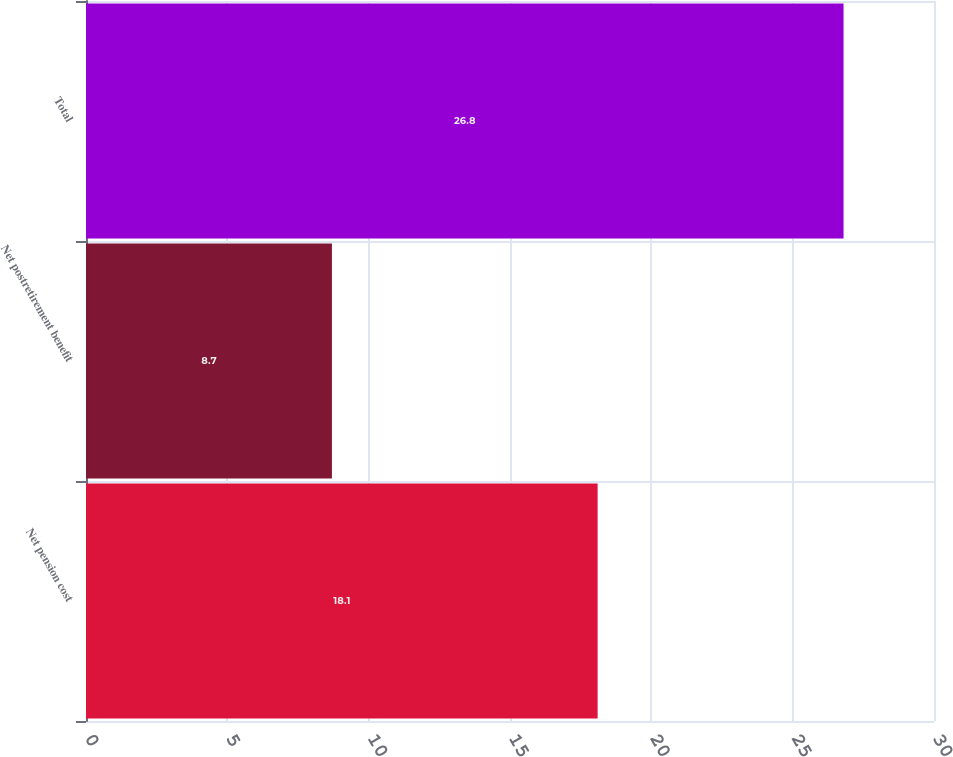Convert chart to OTSL. <chart><loc_0><loc_0><loc_500><loc_500><bar_chart><fcel>Net pension cost<fcel>Net postretirement benefit<fcel>Total<nl><fcel>18.1<fcel>8.7<fcel>26.8<nl></chart> 